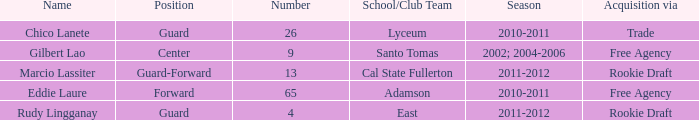Could you parse the entire table? {'header': ['Name', 'Position', 'Number', 'School/Club Team', 'Season', 'Acquisition via'], 'rows': [['Chico Lanete', 'Guard', '26', 'Lyceum', '2010-2011', 'Trade'], ['Gilbert Lao', 'Center', '9', 'Santo Tomas', '2002; 2004-2006', 'Free Agency'], ['Marcio Lassiter', 'Guard-Forward', '13', 'Cal State Fullerton', '2011-2012', 'Rookie Draft'], ['Eddie Laure', 'Forward', '65', 'Adamson', '2010-2011', 'Free Agency'], ['Rudy Lingganay', 'Guard', '4', 'East', '2011-2012', 'Rookie Draft']]} What number has an acquisition via the Rookie Draft, and is part of a School/club team at Cal State Fullerton? 13.0. 